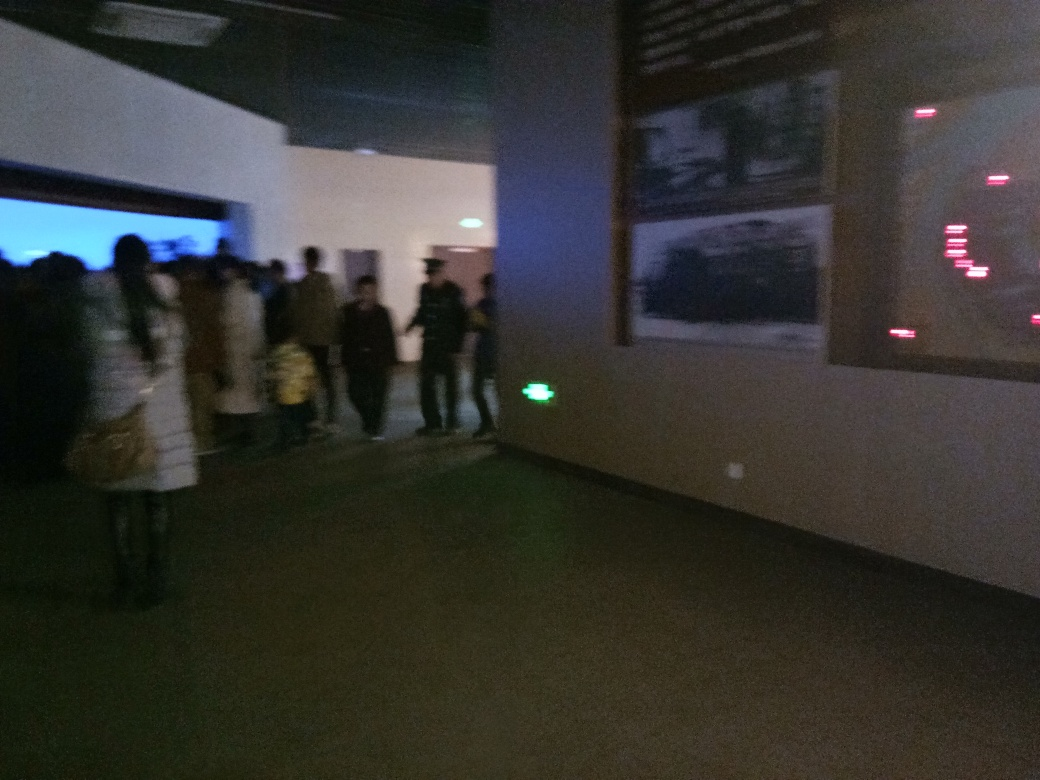Can you describe what the people in the image might be doing? Although the image is quite blurry, it appears that the group of people are gathered inside a dimly lit indoor space, possibly waiting in line for an event or exhibition, given the environment seems to resemble a gallery or event space. 